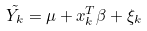Convert formula to latex. <formula><loc_0><loc_0><loc_500><loc_500>\tilde { Y _ { k } } = \mu + x _ { k } ^ { T } \beta + \xi _ { k }</formula> 